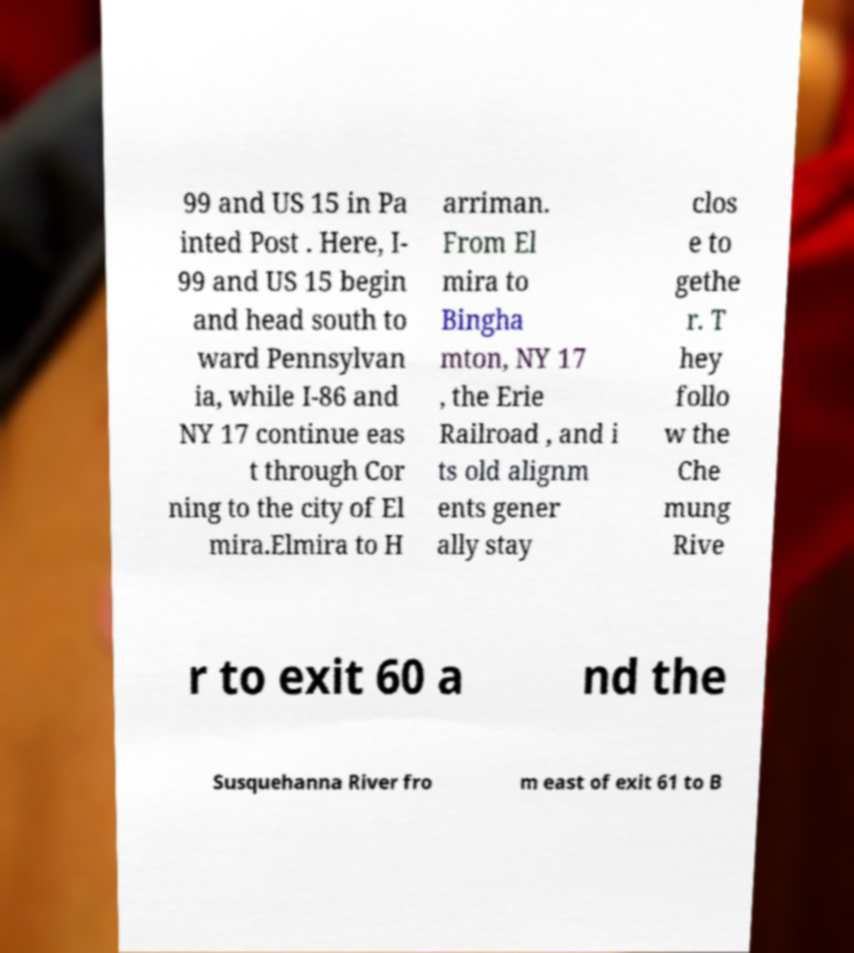There's text embedded in this image that I need extracted. Can you transcribe it verbatim? 99 and US 15 in Pa inted Post . Here, I- 99 and US 15 begin and head south to ward Pennsylvan ia, while I-86 and NY 17 continue eas t through Cor ning to the city of El mira.Elmira to H arriman. From El mira to Bingha mton, NY 17 , the Erie Railroad , and i ts old alignm ents gener ally stay clos e to gethe r. T hey follo w the Che mung Rive r to exit 60 a nd the Susquehanna River fro m east of exit 61 to B 